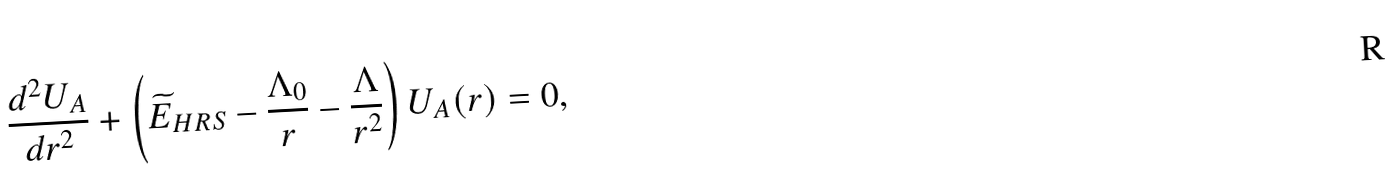<formula> <loc_0><loc_0><loc_500><loc_500>\frac { d ^ { 2 } U _ { A } } { d r ^ { 2 } } + \left ( \widetilde { E } _ { H R S } - \frac { \Lambda _ { 0 } } { r } - \frac { \Lambda } { r ^ { 2 } } \right ) U _ { A } ( r ) = 0 ,</formula> 